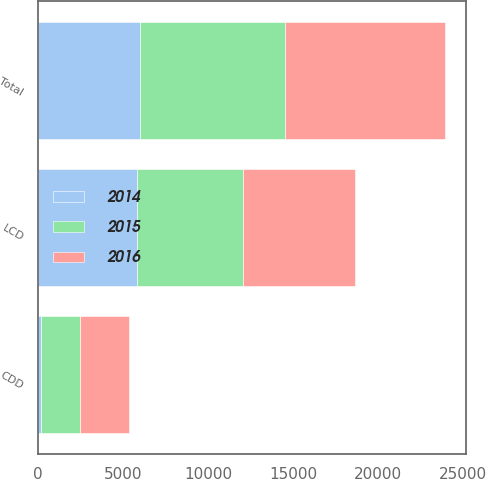<chart> <loc_0><loc_0><loc_500><loc_500><stacked_bar_chart><ecel><fcel>LCD<fcel>CDD<fcel>Total<nl><fcel>2016<fcel>6593.9<fcel>2844.1<fcel>9437.2<nl><fcel>2015<fcel>6199.3<fcel>2306.4<fcel>8505.7<nl><fcel>2014<fcel>5838<fcel>173.6<fcel>6011.6<nl></chart> 